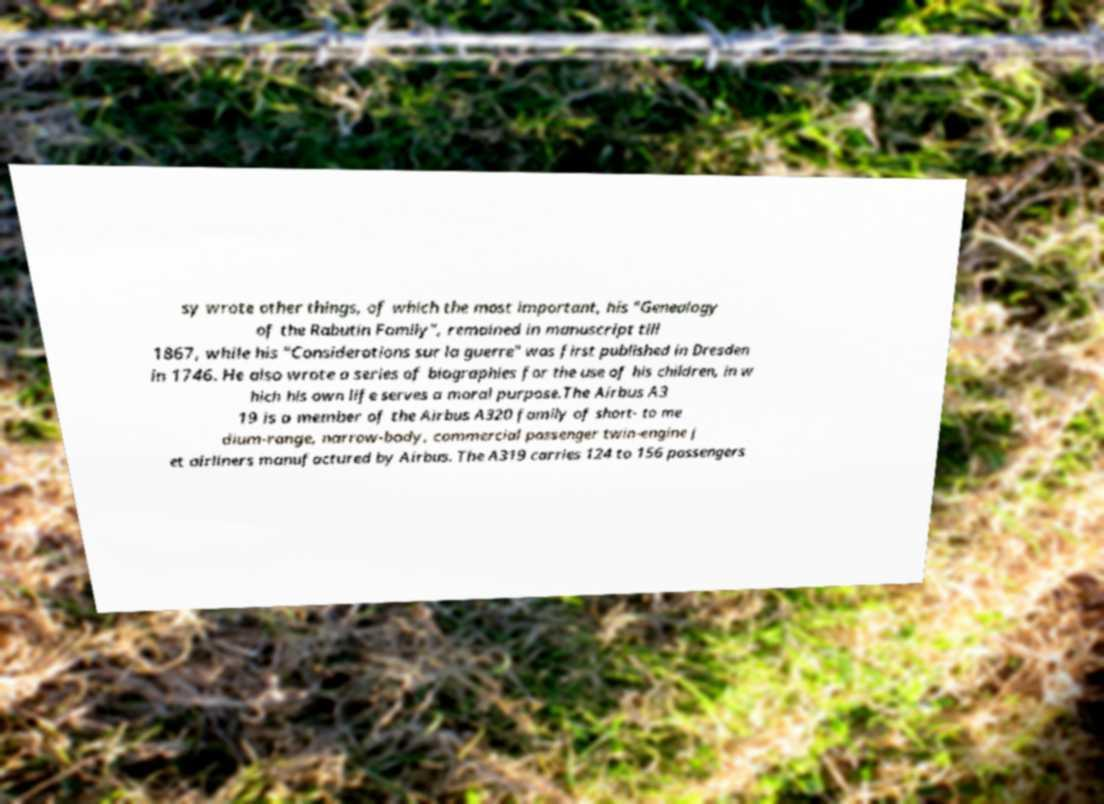Can you read and provide the text displayed in the image?This photo seems to have some interesting text. Can you extract and type it out for me? sy wrote other things, of which the most important, his "Genealogy of the Rabutin Family", remained in manuscript till 1867, while his "Considerations sur la guerre" was first published in Dresden in 1746. He also wrote a series of biographies for the use of his children, in w hich his own life serves a moral purpose.The Airbus A3 19 is a member of the Airbus A320 family of short- to me dium-range, narrow-body, commercial passenger twin-engine j et airliners manufactured by Airbus. The A319 carries 124 to 156 passengers 